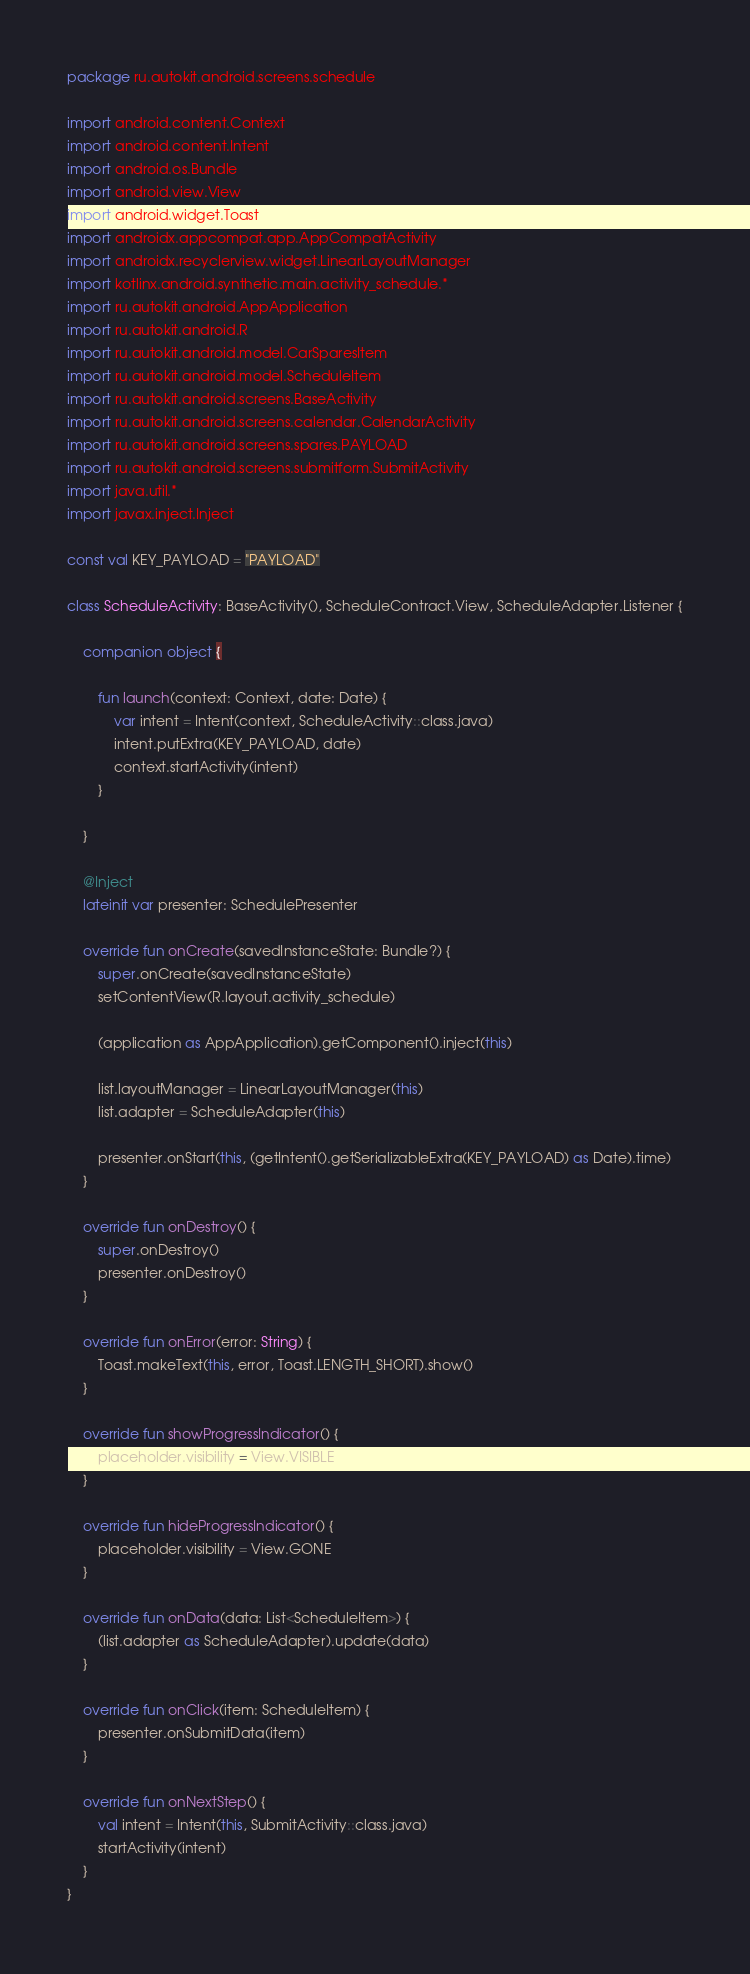Convert code to text. <code><loc_0><loc_0><loc_500><loc_500><_Kotlin_>package ru.autokit.android.screens.schedule

import android.content.Context
import android.content.Intent
import android.os.Bundle
import android.view.View
import android.widget.Toast
import androidx.appcompat.app.AppCompatActivity
import androidx.recyclerview.widget.LinearLayoutManager
import kotlinx.android.synthetic.main.activity_schedule.*
import ru.autokit.android.AppApplication
import ru.autokit.android.R
import ru.autokit.android.model.CarSparesItem
import ru.autokit.android.model.ScheduleItem
import ru.autokit.android.screens.BaseActivity
import ru.autokit.android.screens.calendar.CalendarActivity
import ru.autokit.android.screens.spares.PAYLOAD
import ru.autokit.android.screens.submitform.SubmitActivity
import java.util.*
import javax.inject.Inject

const val KEY_PAYLOAD = "PAYLOAD"

class ScheduleActivity: BaseActivity(), ScheduleContract.View, ScheduleAdapter.Listener {

    companion object {

        fun launch(context: Context, date: Date) {
            var intent = Intent(context, ScheduleActivity::class.java)
            intent.putExtra(KEY_PAYLOAD, date)
            context.startActivity(intent)
        }

    }

    @Inject
    lateinit var presenter: SchedulePresenter

    override fun onCreate(savedInstanceState: Bundle?) {
        super.onCreate(savedInstanceState)
        setContentView(R.layout.activity_schedule)

        (application as AppApplication).getComponent().inject(this)

        list.layoutManager = LinearLayoutManager(this)
        list.adapter = ScheduleAdapter(this)

        presenter.onStart(this, (getIntent().getSerializableExtra(KEY_PAYLOAD) as Date).time)
    }

    override fun onDestroy() {
        super.onDestroy()
        presenter.onDestroy()
    }

    override fun onError(error: String) {
        Toast.makeText(this, error, Toast.LENGTH_SHORT).show()
    }

    override fun showProgressIndicator() {
        placeholder.visibility = View.VISIBLE
    }

    override fun hideProgressIndicator() {
        placeholder.visibility = View.GONE
    }

    override fun onData(data: List<ScheduleItem>) {
        (list.adapter as ScheduleAdapter).update(data)
    }

    override fun onClick(item: ScheduleItem) {
        presenter.onSubmitData(item)
    }

    override fun onNextStep() {
        val intent = Intent(this, SubmitActivity::class.java)
        startActivity(intent)
    }
}</code> 